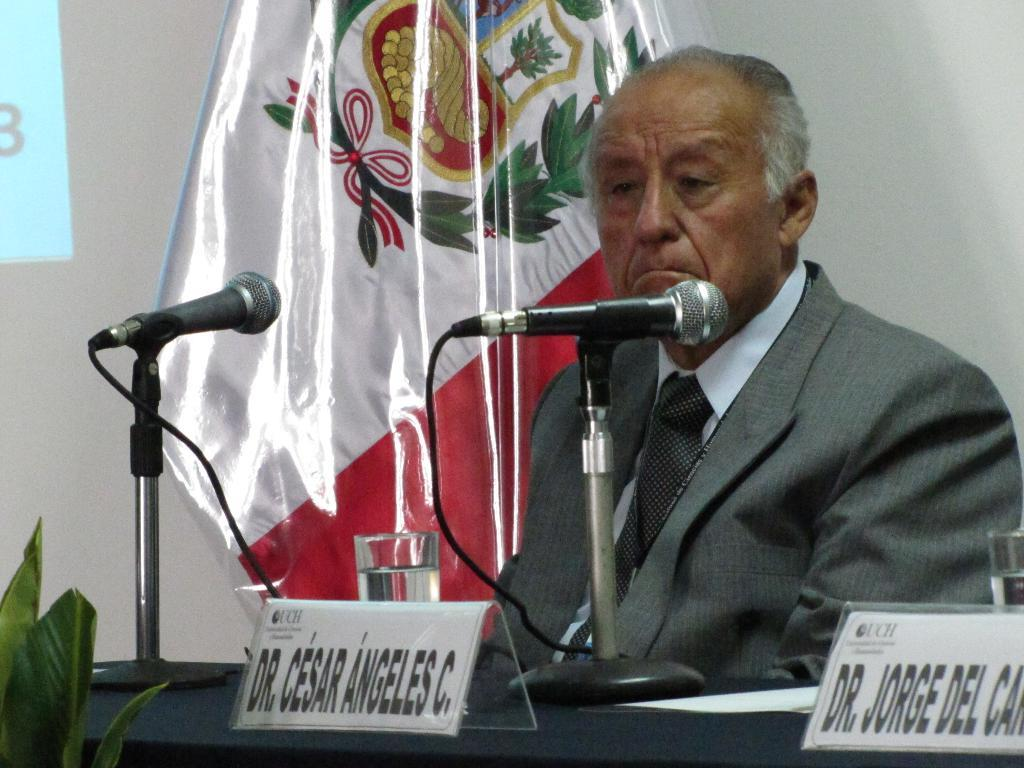What is present in the image that is used for covering or decoration? There is a cloth in the image. What is present in the image that represents a country or organization? There is a flag in the image. What is present in the image that displays information or images? There is a screen in the image. What is present in the image that is used for amplifying sound? There are microphones (mics) in the image. What is present in the image that is used for placing objects or supporting activities? There is a table in the image. What is present in the image that indicates a person is seated? There is a man sitting in the image. What type of account is the man opening in the image? There is no indication of an account being opened in the image; the man is simply sitting. What causes the shock in the image? There is no shock or any indication of a shocking event in the image. 